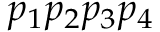<formula> <loc_0><loc_0><loc_500><loc_500>p _ { 1 } p _ { 2 } p _ { 3 } p _ { 4 }</formula> 